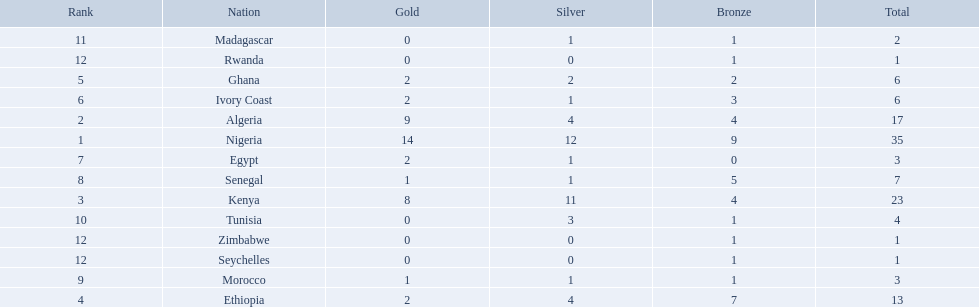What are all the nations? Nigeria, Algeria, Kenya, Ethiopia, Ghana, Ivory Coast, Egypt, Senegal, Morocco, Tunisia, Madagascar, Rwanda, Zimbabwe, Seychelles. How many bronze medals did they win? 9, 4, 4, 7, 2, 3, 0, 5, 1, 1, 1, 1, 1, 1. And which nation did not win one? Egypt. 